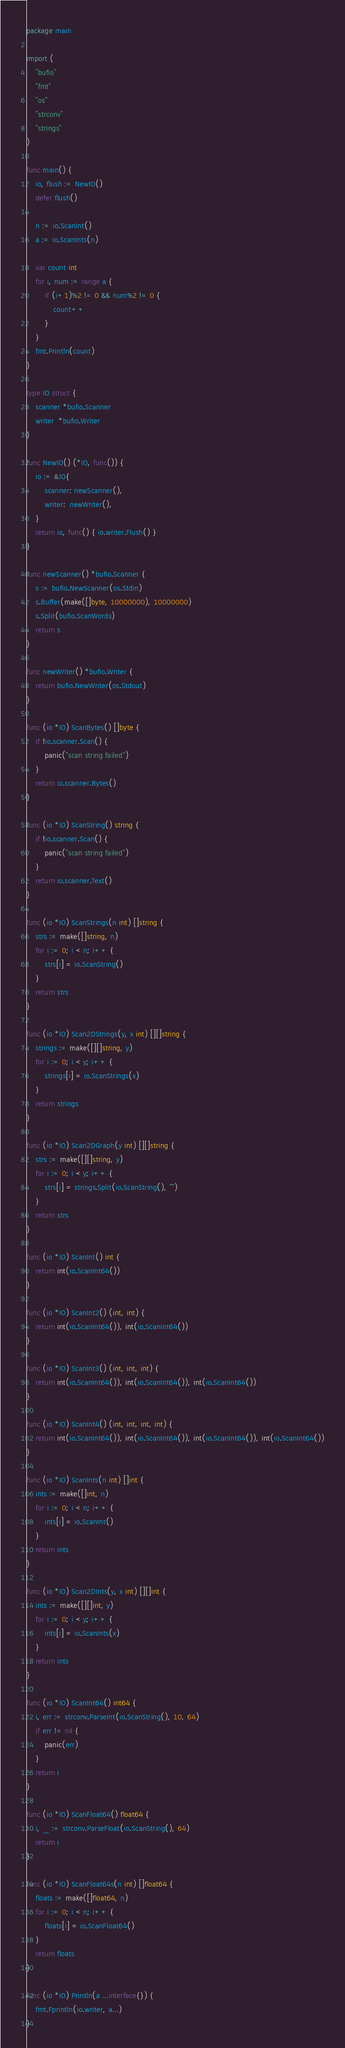<code> <loc_0><loc_0><loc_500><loc_500><_Go_>package main

import (
	"bufio"
	"fmt"
	"os"
	"strconv"
	"strings"
)

func main() {
	io, flush := NewIO()
	defer flush()

	n := io.ScanInt()
	a := io.ScanInts(n)

	var count int
	for i, num := range a {
		if (i+1)%2 != 0 && num%2 != 0 {
			count++
		}
	}
	fmt.Println(count)
}

type IO struct {
	scanner *bufio.Scanner
	writer  *bufio.Writer
}

func NewIO() (*IO, func()) {
	io := &IO{
		scanner: newScanner(),
		writer:  newWriter(),
	}
	return io, func() { io.writer.Flush() }
}

func newScanner() *bufio.Scanner {
	s := bufio.NewScanner(os.Stdin)
	s.Buffer(make([]byte, 10000000), 10000000)
	s.Split(bufio.ScanWords)
	return s
}

func newWriter() *bufio.Writer {
	return bufio.NewWriter(os.Stdout)
}

func (io *IO) ScanBytes() []byte {
	if !io.scanner.Scan() {
		panic("scan string failed")
	}
	return io.scanner.Bytes()
}

func (io *IO) ScanString() string {
	if !io.scanner.Scan() {
		panic("scan string failed")
	}
	return io.scanner.Text()
}

func (io *IO) ScanStrings(n int) []string {
	strs := make([]string, n)
	for i := 0; i < n; i++ {
		strs[i] = io.ScanString()
	}
	return strs
}

func (io *IO) Scan2DStrings(y, x int) [][]string {
	strings := make([][]string, y)
	for i := 0; i < y; i++ {
		strings[i] = io.ScanStrings(x)
	}
	return strings
}

func (io *IO) Scan2DGraph(y int) [][]string {
	strs := make([][]string, y)
	for i := 0; i < y; i++ {
		strs[i] = strings.Split(io.ScanString(), "")
	}
	return strs
}

func (io *IO) ScanInt() int {
	return int(io.ScanInt64())
}

func (io *IO) ScanInt2() (int, int) {
	return int(io.ScanInt64()), int(io.ScanInt64())
}

func (io *IO) ScanInt3() (int, int, int) {
	return int(io.ScanInt64()), int(io.ScanInt64()), int(io.ScanInt64())
}

func (io *IO) ScanInt4() (int, int, int, int) {
	return int(io.ScanInt64()), int(io.ScanInt64()), int(io.ScanInt64()), int(io.ScanInt64())
}

func (io *IO) ScanInts(n int) []int {
	ints := make([]int, n)
	for i := 0; i < n; i++ {
		ints[i] = io.ScanInt()
	}
	return ints
}

func (io *IO) Scan2DInts(y, x int) [][]int {
	ints := make([][]int, y)
	for i := 0; i < y; i++ {
		ints[i] = io.ScanInts(x)
	}
	return ints
}

func (io *IO) ScanInt64() int64 {
	i, err := strconv.ParseInt(io.ScanString(), 10, 64)
	if err != nil {
		panic(err)
	}
	return i
}

func (io *IO) ScanFloat64() float64 {
	i, _ := strconv.ParseFloat(io.ScanString(), 64)
	return i
}

func (io *IO) ScanFloat64s(n int) []float64 {
	floats := make([]float64, n)
	for i := 0; i < n; i++ {
		floats[i] = io.ScanFloat64()
	}
	return floats
}

func (io *IO) Println(a ...interface{}) {
	fmt.Fprintln(io.writer, a...)
}
</code> 